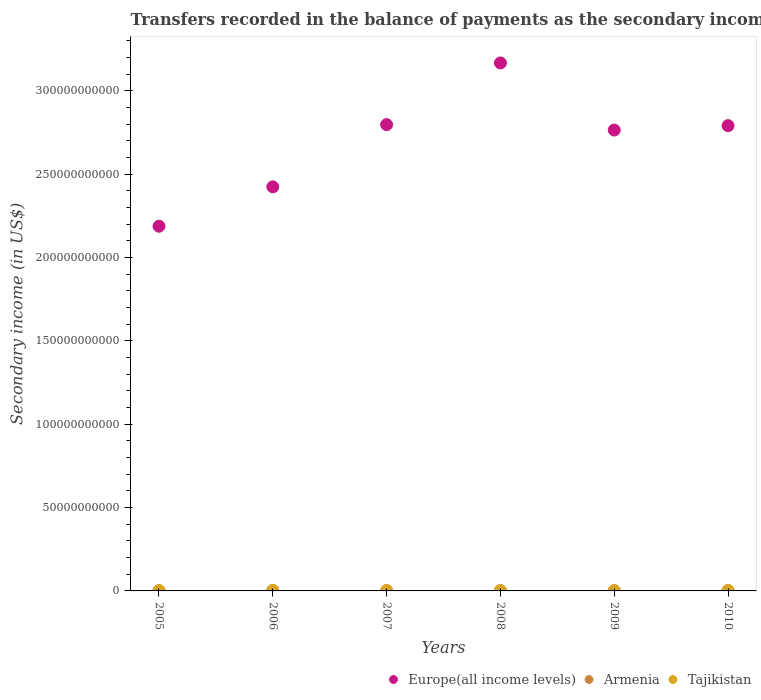Is the number of dotlines equal to the number of legend labels?
Your answer should be very brief. Yes. What is the secondary income of in Europe(all income levels) in 2006?
Offer a terse response. 2.42e+11. Across all years, what is the maximum secondary income of in Armenia?
Give a very brief answer. 2.08e+08. Across all years, what is the minimum secondary income of in Tajikistan?
Keep it short and to the point. 1.27e+08. In which year was the secondary income of in Armenia maximum?
Offer a very short reply. 2008. What is the total secondary income of in Tajikistan in the graph?
Provide a short and direct response. 1.35e+09. What is the difference between the secondary income of in Europe(all income levels) in 2006 and that in 2008?
Your answer should be compact. -7.43e+1. What is the difference between the secondary income of in Europe(all income levels) in 2010 and the secondary income of in Armenia in 2009?
Your answer should be compact. 2.79e+11. What is the average secondary income of in Tajikistan per year?
Provide a succinct answer. 2.25e+08. In the year 2009, what is the difference between the secondary income of in Armenia and secondary income of in Tajikistan?
Provide a short and direct response. 3.81e+07. What is the ratio of the secondary income of in Europe(all income levels) in 2007 to that in 2008?
Provide a short and direct response. 0.88. What is the difference between the highest and the second highest secondary income of in Europe(all income levels)?
Offer a very short reply. 3.70e+1. What is the difference between the highest and the lowest secondary income of in Armenia?
Ensure brevity in your answer.  5.76e+07. Is the sum of the secondary income of in Europe(all income levels) in 2005 and 2009 greater than the maximum secondary income of in Tajikistan across all years?
Keep it short and to the point. Yes. Is it the case that in every year, the sum of the secondary income of in Europe(all income levels) and secondary income of in Armenia  is greater than the secondary income of in Tajikistan?
Your answer should be very brief. Yes. Does the secondary income of in Armenia monotonically increase over the years?
Offer a terse response. No. What is the difference between two consecutive major ticks on the Y-axis?
Ensure brevity in your answer.  5.00e+1. Are the values on the major ticks of Y-axis written in scientific E-notation?
Make the answer very short. No. Does the graph contain any zero values?
Ensure brevity in your answer.  No. Where does the legend appear in the graph?
Make the answer very short. Bottom right. What is the title of the graph?
Ensure brevity in your answer.  Transfers recorded in the balance of payments as the secondary income of a country. What is the label or title of the Y-axis?
Give a very brief answer. Secondary income (in US$). What is the Secondary income (in US$) of Europe(all income levels) in 2005?
Offer a very short reply. 2.19e+11. What is the Secondary income (in US$) in Armenia in 2005?
Keep it short and to the point. 1.53e+08. What is the Secondary income (in US$) in Tajikistan in 2005?
Give a very brief answer. 1.50e+08. What is the Secondary income (in US$) in Europe(all income levels) in 2006?
Give a very brief answer. 2.42e+11. What is the Secondary income (in US$) in Armenia in 2006?
Offer a very short reply. 1.51e+08. What is the Secondary income (in US$) of Tajikistan in 2006?
Offer a terse response. 4.00e+08. What is the Secondary income (in US$) in Europe(all income levels) in 2007?
Give a very brief answer. 2.80e+11. What is the Secondary income (in US$) in Armenia in 2007?
Your answer should be very brief. 2.04e+08. What is the Secondary income (in US$) of Tajikistan in 2007?
Your response must be concise. 2.37e+08. What is the Secondary income (in US$) in Europe(all income levels) in 2008?
Give a very brief answer. 3.17e+11. What is the Secondary income (in US$) in Armenia in 2008?
Ensure brevity in your answer.  2.08e+08. What is the Secondary income (in US$) of Tajikistan in 2008?
Your response must be concise. 2.07e+08. What is the Secondary income (in US$) in Europe(all income levels) in 2009?
Offer a very short reply. 2.76e+11. What is the Secondary income (in US$) of Armenia in 2009?
Keep it short and to the point. 1.65e+08. What is the Secondary income (in US$) of Tajikistan in 2009?
Your answer should be very brief. 1.27e+08. What is the Secondary income (in US$) of Europe(all income levels) in 2010?
Ensure brevity in your answer.  2.79e+11. What is the Secondary income (in US$) in Armenia in 2010?
Offer a terse response. 2.03e+08. What is the Secondary income (in US$) in Tajikistan in 2010?
Offer a very short reply. 2.27e+08. Across all years, what is the maximum Secondary income (in US$) in Europe(all income levels)?
Your answer should be compact. 3.17e+11. Across all years, what is the maximum Secondary income (in US$) of Armenia?
Your answer should be compact. 2.08e+08. Across all years, what is the maximum Secondary income (in US$) of Tajikistan?
Provide a succinct answer. 4.00e+08. Across all years, what is the minimum Secondary income (in US$) of Europe(all income levels)?
Your answer should be very brief. 2.19e+11. Across all years, what is the minimum Secondary income (in US$) in Armenia?
Provide a short and direct response. 1.51e+08. Across all years, what is the minimum Secondary income (in US$) of Tajikistan?
Offer a very short reply. 1.27e+08. What is the total Secondary income (in US$) of Europe(all income levels) in the graph?
Ensure brevity in your answer.  1.61e+12. What is the total Secondary income (in US$) of Armenia in the graph?
Make the answer very short. 1.08e+09. What is the total Secondary income (in US$) in Tajikistan in the graph?
Keep it short and to the point. 1.35e+09. What is the difference between the Secondary income (in US$) of Europe(all income levels) in 2005 and that in 2006?
Offer a very short reply. -2.36e+1. What is the difference between the Secondary income (in US$) of Armenia in 2005 and that in 2006?
Your response must be concise. 2.45e+06. What is the difference between the Secondary income (in US$) of Tajikistan in 2005 and that in 2006?
Give a very brief answer. -2.50e+08. What is the difference between the Secondary income (in US$) of Europe(all income levels) in 2005 and that in 2007?
Your answer should be compact. -6.10e+1. What is the difference between the Secondary income (in US$) of Armenia in 2005 and that in 2007?
Your response must be concise. -5.10e+07. What is the difference between the Secondary income (in US$) in Tajikistan in 2005 and that in 2007?
Your response must be concise. -8.72e+07. What is the difference between the Secondary income (in US$) of Europe(all income levels) in 2005 and that in 2008?
Provide a short and direct response. -9.80e+1. What is the difference between the Secondary income (in US$) of Armenia in 2005 and that in 2008?
Your response must be concise. -5.51e+07. What is the difference between the Secondary income (in US$) of Tajikistan in 2005 and that in 2008?
Provide a short and direct response. -5.68e+07. What is the difference between the Secondary income (in US$) in Europe(all income levels) in 2005 and that in 2009?
Make the answer very short. -5.77e+1. What is the difference between the Secondary income (in US$) of Armenia in 2005 and that in 2009?
Your answer should be very brief. -1.18e+07. What is the difference between the Secondary income (in US$) of Tajikistan in 2005 and that in 2009?
Make the answer very short. 2.31e+07. What is the difference between the Secondary income (in US$) of Europe(all income levels) in 2005 and that in 2010?
Your response must be concise. -6.03e+1. What is the difference between the Secondary income (in US$) in Armenia in 2005 and that in 2010?
Make the answer very short. -4.98e+07. What is the difference between the Secondary income (in US$) of Tajikistan in 2005 and that in 2010?
Provide a short and direct response. -7.67e+07. What is the difference between the Secondary income (in US$) of Europe(all income levels) in 2006 and that in 2007?
Offer a terse response. -3.73e+1. What is the difference between the Secondary income (in US$) in Armenia in 2006 and that in 2007?
Give a very brief answer. -5.34e+07. What is the difference between the Secondary income (in US$) in Tajikistan in 2006 and that in 2007?
Your answer should be compact. 1.63e+08. What is the difference between the Secondary income (in US$) of Europe(all income levels) in 2006 and that in 2008?
Offer a very short reply. -7.43e+1. What is the difference between the Secondary income (in US$) of Armenia in 2006 and that in 2008?
Ensure brevity in your answer.  -5.76e+07. What is the difference between the Secondary income (in US$) in Tajikistan in 2006 and that in 2008?
Your response must be concise. 1.94e+08. What is the difference between the Secondary income (in US$) in Europe(all income levels) in 2006 and that in 2009?
Provide a succinct answer. -3.41e+1. What is the difference between the Secondary income (in US$) in Armenia in 2006 and that in 2009?
Offer a terse response. -1.43e+07. What is the difference between the Secondary income (in US$) of Tajikistan in 2006 and that in 2009?
Offer a terse response. 2.73e+08. What is the difference between the Secondary income (in US$) of Europe(all income levels) in 2006 and that in 2010?
Ensure brevity in your answer.  -3.67e+1. What is the difference between the Secondary income (in US$) of Armenia in 2006 and that in 2010?
Offer a terse response. -5.23e+07. What is the difference between the Secondary income (in US$) in Tajikistan in 2006 and that in 2010?
Provide a succinct answer. 1.74e+08. What is the difference between the Secondary income (in US$) in Europe(all income levels) in 2007 and that in 2008?
Provide a succinct answer. -3.70e+1. What is the difference between the Secondary income (in US$) in Armenia in 2007 and that in 2008?
Provide a short and direct response. -4.16e+06. What is the difference between the Secondary income (in US$) in Tajikistan in 2007 and that in 2008?
Give a very brief answer. 3.03e+07. What is the difference between the Secondary income (in US$) of Europe(all income levels) in 2007 and that in 2009?
Keep it short and to the point. 3.27e+09. What is the difference between the Secondary income (in US$) of Armenia in 2007 and that in 2009?
Keep it short and to the point. 3.92e+07. What is the difference between the Secondary income (in US$) in Tajikistan in 2007 and that in 2009?
Your response must be concise. 1.10e+08. What is the difference between the Secondary income (in US$) of Europe(all income levels) in 2007 and that in 2010?
Your answer should be very brief. 6.19e+08. What is the difference between the Secondary income (in US$) of Armenia in 2007 and that in 2010?
Offer a very short reply. 1.17e+06. What is the difference between the Secondary income (in US$) in Tajikistan in 2007 and that in 2010?
Your answer should be compact. 1.05e+07. What is the difference between the Secondary income (in US$) of Europe(all income levels) in 2008 and that in 2009?
Give a very brief answer. 4.03e+1. What is the difference between the Secondary income (in US$) in Armenia in 2008 and that in 2009?
Your answer should be very brief. 4.33e+07. What is the difference between the Secondary income (in US$) in Tajikistan in 2008 and that in 2009?
Offer a terse response. 7.99e+07. What is the difference between the Secondary income (in US$) of Europe(all income levels) in 2008 and that in 2010?
Offer a terse response. 3.76e+1. What is the difference between the Secondary income (in US$) in Armenia in 2008 and that in 2010?
Your answer should be very brief. 5.33e+06. What is the difference between the Secondary income (in US$) of Tajikistan in 2008 and that in 2010?
Your answer should be very brief. -1.98e+07. What is the difference between the Secondary income (in US$) in Europe(all income levels) in 2009 and that in 2010?
Give a very brief answer. -2.65e+09. What is the difference between the Secondary income (in US$) in Armenia in 2009 and that in 2010?
Offer a terse response. -3.80e+07. What is the difference between the Secondary income (in US$) in Tajikistan in 2009 and that in 2010?
Provide a succinct answer. -9.97e+07. What is the difference between the Secondary income (in US$) of Europe(all income levels) in 2005 and the Secondary income (in US$) of Armenia in 2006?
Your answer should be compact. 2.19e+11. What is the difference between the Secondary income (in US$) of Europe(all income levels) in 2005 and the Secondary income (in US$) of Tajikistan in 2006?
Offer a terse response. 2.18e+11. What is the difference between the Secondary income (in US$) of Armenia in 2005 and the Secondary income (in US$) of Tajikistan in 2006?
Provide a succinct answer. -2.47e+08. What is the difference between the Secondary income (in US$) of Europe(all income levels) in 2005 and the Secondary income (in US$) of Armenia in 2007?
Provide a short and direct response. 2.19e+11. What is the difference between the Secondary income (in US$) of Europe(all income levels) in 2005 and the Secondary income (in US$) of Tajikistan in 2007?
Ensure brevity in your answer.  2.19e+11. What is the difference between the Secondary income (in US$) in Armenia in 2005 and the Secondary income (in US$) in Tajikistan in 2007?
Give a very brief answer. -8.39e+07. What is the difference between the Secondary income (in US$) in Europe(all income levels) in 2005 and the Secondary income (in US$) in Armenia in 2008?
Give a very brief answer. 2.19e+11. What is the difference between the Secondary income (in US$) of Europe(all income levels) in 2005 and the Secondary income (in US$) of Tajikistan in 2008?
Keep it short and to the point. 2.19e+11. What is the difference between the Secondary income (in US$) of Armenia in 2005 and the Secondary income (in US$) of Tajikistan in 2008?
Keep it short and to the point. -5.36e+07. What is the difference between the Secondary income (in US$) in Europe(all income levels) in 2005 and the Secondary income (in US$) in Armenia in 2009?
Your answer should be compact. 2.19e+11. What is the difference between the Secondary income (in US$) in Europe(all income levels) in 2005 and the Secondary income (in US$) in Tajikistan in 2009?
Offer a very short reply. 2.19e+11. What is the difference between the Secondary income (in US$) of Armenia in 2005 and the Secondary income (in US$) of Tajikistan in 2009?
Ensure brevity in your answer.  2.63e+07. What is the difference between the Secondary income (in US$) in Europe(all income levels) in 2005 and the Secondary income (in US$) in Armenia in 2010?
Make the answer very short. 2.19e+11. What is the difference between the Secondary income (in US$) of Europe(all income levels) in 2005 and the Secondary income (in US$) of Tajikistan in 2010?
Provide a succinct answer. 2.19e+11. What is the difference between the Secondary income (in US$) of Armenia in 2005 and the Secondary income (in US$) of Tajikistan in 2010?
Provide a short and direct response. -7.34e+07. What is the difference between the Secondary income (in US$) in Europe(all income levels) in 2006 and the Secondary income (in US$) in Armenia in 2007?
Your answer should be compact. 2.42e+11. What is the difference between the Secondary income (in US$) in Europe(all income levels) in 2006 and the Secondary income (in US$) in Tajikistan in 2007?
Make the answer very short. 2.42e+11. What is the difference between the Secondary income (in US$) of Armenia in 2006 and the Secondary income (in US$) of Tajikistan in 2007?
Ensure brevity in your answer.  -8.64e+07. What is the difference between the Secondary income (in US$) of Europe(all income levels) in 2006 and the Secondary income (in US$) of Armenia in 2008?
Provide a succinct answer. 2.42e+11. What is the difference between the Secondary income (in US$) of Europe(all income levels) in 2006 and the Secondary income (in US$) of Tajikistan in 2008?
Give a very brief answer. 2.42e+11. What is the difference between the Secondary income (in US$) in Armenia in 2006 and the Secondary income (in US$) in Tajikistan in 2008?
Make the answer very short. -5.61e+07. What is the difference between the Secondary income (in US$) in Europe(all income levels) in 2006 and the Secondary income (in US$) in Armenia in 2009?
Offer a very short reply. 2.42e+11. What is the difference between the Secondary income (in US$) of Europe(all income levels) in 2006 and the Secondary income (in US$) of Tajikistan in 2009?
Your answer should be very brief. 2.42e+11. What is the difference between the Secondary income (in US$) in Armenia in 2006 and the Secondary income (in US$) in Tajikistan in 2009?
Keep it short and to the point. 2.38e+07. What is the difference between the Secondary income (in US$) in Europe(all income levels) in 2006 and the Secondary income (in US$) in Armenia in 2010?
Provide a succinct answer. 2.42e+11. What is the difference between the Secondary income (in US$) of Europe(all income levels) in 2006 and the Secondary income (in US$) of Tajikistan in 2010?
Your response must be concise. 2.42e+11. What is the difference between the Secondary income (in US$) in Armenia in 2006 and the Secondary income (in US$) in Tajikistan in 2010?
Give a very brief answer. -7.59e+07. What is the difference between the Secondary income (in US$) in Europe(all income levels) in 2007 and the Secondary income (in US$) in Armenia in 2008?
Your response must be concise. 2.80e+11. What is the difference between the Secondary income (in US$) in Europe(all income levels) in 2007 and the Secondary income (in US$) in Tajikistan in 2008?
Provide a succinct answer. 2.80e+11. What is the difference between the Secondary income (in US$) in Armenia in 2007 and the Secondary income (in US$) in Tajikistan in 2008?
Provide a short and direct response. -2.63e+06. What is the difference between the Secondary income (in US$) of Europe(all income levels) in 2007 and the Secondary income (in US$) of Armenia in 2009?
Your answer should be very brief. 2.80e+11. What is the difference between the Secondary income (in US$) in Europe(all income levels) in 2007 and the Secondary income (in US$) in Tajikistan in 2009?
Your answer should be compact. 2.80e+11. What is the difference between the Secondary income (in US$) of Armenia in 2007 and the Secondary income (in US$) of Tajikistan in 2009?
Keep it short and to the point. 7.73e+07. What is the difference between the Secondary income (in US$) of Europe(all income levels) in 2007 and the Secondary income (in US$) of Armenia in 2010?
Provide a succinct answer. 2.80e+11. What is the difference between the Secondary income (in US$) of Europe(all income levels) in 2007 and the Secondary income (in US$) of Tajikistan in 2010?
Your answer should be very brief. 2.80e+11. What is the difference between the Secondary income (in US$) of Armenia in 2007 and the Secondary income (in US$) of Tajikistan in 2010?
Offer a terse response. -2.25e+07. What is the difference between the Secondary income (in US$) of Europe(all income levels) in 2008 and the Secondary income (in US$) of Armenia in 2009?
Give a very brief answer. 3.17e+11. What is the difference between the Secondary income (in US$) of Europe(all income levels) in 2008 and the Secondary income (in US$) of Tajikistan in 2009?
Make the answer very short. 3.17e+11. What is the difference between the Secondary income (in US$) of Armenia in 2008 and the Secondary income (in US$) of Tajikistan in 2009?
Provide a short and direct response. 8.14e+07. What is the difference between the Secondary income (in US$) in Europe(all income levels) in 2008 and the Secondary income (in US$) in Armenia in 2010?
Offer a very short reply. 3.17e+11. What is the difference between the Secondary income (in US$) in Europe(all income levels) in 2008 and the Secondary income (in US$) in Tajikistan in 2010?
Provide a short and direct response. 3.17e+11. What is the difference between the Secondary income (in US$) of Armenia in 2008 and the Secondary income (in US$) of Tajikistan in 2010?
Offer a terse response. -1.83e+07. What is the difference between the Secondary income (in US$) in Europe(all income levels) in 2009 and the Secondary income (in US$) in Armenia in 2010?
Your response must be concise. 2.76e+11. What is the difference between the Secondary income (in US$) of Europe(all income levels) in 2009 and the Secondary income (in US$) of Tajikistan in 2010?
Ensure brevity in your answer.  2.76e+11. What is the difference between the Secondary income (in US$) in Armenia in 2009 and the Secondary income (in US$) in Tajikistan in 2010?
Offer a terse response. -6.16e+07. What is the average Secondary income (in US$) of Europe(all income levels) per year?
Give a very brief answer. 2.69e+11. What is the average Secondary income (in US$) in Armenia per year?
Provide a short and direct response. 1.81e+08. What is the average Secondary income (in US$) in Tajikistan per year?
Make the answer very short. 2.25e+08. In the year 2005, what is the difference between the Secondary income (in US$) of Europe(all income levels) and Secondary income (in US$) of Armenia?
Ensure brevity in your answer.  2.19e+11. In the year 2005, what is the difference between the Secondary income (in US$) in Europe(all income levels) and Secondary income (in US$) in Tajikistan?
Your answer should be compact. 2.19e+11. In the year 2005, what is the difference between the Secondary income (in US$) of Armenia and Secondary income (in US$) of Tajikistan?
Give a very brief answer. 3.24e+06. In the year 2006, what is the difference between the Secondary income (in US$) of Europe(all income levels) and Secondary income (in US$) of Armenia?
Your answer should be compact. 2.42e+11. In the year 2006, what is the difference between the Secondary income (in US$) of Europe(all income levels) and Secondary income (in US$) of Tajikistan?
Offer a very short reply. 2.42e+11. In the year 2006, what is the difference between the Secondary income (in US$) in Armenia and Secondary income (in US$) in Tajikistan?
Ensure brevity in your answer.  -2.50e+08. In the year 2007, what is the difference between the Secondary income (in US$) in Europe(all income levels) and Secondary income (in US$) in Armenia?
Offer a very short reply. 2.80e+11. In the year 2007, what is the difference between the Secondary income (in US$) of Europe(all income levels) and Secondary income (in US$) of Tajikistan?
Your answer should be compact. 2.80e+11. In the year 2007, what is the difference between the Secondary income (in US$) in Armenia and Secondary income (in US$) in Tajikistan?
Give a very brief answer. -3.29e+07. In the year 2008, what is the difference between the Secondary income (in US$) of Europe(all income levels) and Secondary income (in US$) of Armenia?
Your answer should be very brief. 3.17e+11. In the year 2008, what is the difference between the Secondary income (in US$) of Europe(all income levels) and Secondary income (in US$) of Tajikistan?
Provide a short and direct response. 3.17e+11. In the year 2008, what is the difference between the Secondary income (in US$) in Armenia and Secondary income (in US$) in Tajikistan?
Your answer should be very brief. 1.53e+06. In the year 2009, what is the difference between the Secondary income (in US$) of Europe(all income levels) and Secondary income (in US$) of Armenia?
Offer a terse response. 2.76e+11. In the year 2009, what is the difference between the Secondary income (in US$) in Europe(all income levels) and Secondary income (in US$) in Tajikistan?
Ensure brevity in your answer.  2.76e+11. In the year 2009, what is the difference between the Secondary income (in US$) of Armenia and Secondary income (in US$) of Tajikistan?
Your answer should be very brief. 3.81e+07. In the year 2010, what is the difference between the Secondary income (in US$) in Europe(all income levels) and Secondary income (in US$) in Armenia?
Offer a terse response. 2.79e+11. In the year 2010, what is the difference between the Secondary income (in US$) in Europe(all income levels) and Secondary income (in US$) in Tajikistan?
Keep it short and to the point. 2.79e+11. In the year 2010, what is the difference between the Secondary income (in US$) in Armenia and Secondary income (in US$) in Tajikistan?
Give a very brief answer. -2.36e+07. What is the ratio of the Secondary income (in US$) of Europe(all income levels) in 2005 to that in 2006?
Provide a succinct answer. 0.9. What is the ratio of the Secondary income (in US$) in Armenia in 2005 to that in 2006?
Your answer should be compact. 1.02. What is the ratio of the Secondary income (in US$) of Tajikistan in 2005 to that in 2006?
Your answer should be very brief. 0.37. What is the ratio of the Secondary income (in US$) in Europe(all income levels) in 2005 to that in 2007?
Provide a short and direct response. 0.78. What is the ratio of the Secondary income (in US$) in Armenia in 2005 to that in 2007?
Your answer should be compact. 0.75. What is the ratio of the Secondary income (in US$) of Tajikistan in 2005 to that in 2007?
Make the answer very short. 0.63. What is the ratio of the Secondary income (in US$) of Europe(all income levels) in 2005 to that in 2008?
Offer a terse response. 0.69. What is the ratio of the Secondary income (in US$) in Armenia in 2005 to that in 2008?
Make the answer very short. 0.74. What is the ratio of the Secondary income (in US$) in Tajikistan in 2005 to that in 2008?
Give a very brief answer. 0.73. What is the ratio of the Secondary income (in US$) in Europe(all income levels) in 2005 to that in 2009?
Your answer should be compact. 0.79. What is the ratio of the Secondary income (in US$) in Armenia in 2005 to that in 2009?
Your response must be concise. 0.93. What is the ratio of the Secondary income (in US$) in Tajikistan in 2005 to that in 2009?
Your answer should be very brief. 1.18. What is the ratio of the Secondary income (in US$) of Europe(all income levels) in 2005 to that in 2010?
Make the answer very short. 0.78. What is the ratio of the Secondary income (in US$) in Armenia in 2005 to that in 2010?
Offer a very short reply. 0.75. What is the ratio of the Secondary income (in US$) of Tajikistan in 2005 to that in 2010?
Ensure brevity in your answer.  0.66. What is the ratio of the Secondary income (in US$) in Europe(all income levels) in 2006 to that in 2007?
Make the answer very short. 0.87. What is the ratio of the Secondary income (in US$) in Armenia in 2006 to that in 2007?
Offer a terse response. 0.74. What is the ratio of the Secondary income (in US$) of Tajikistan in 2006 to that in 2007?
Ensure brevity in your answer.  1.69. What is the ratio of the Secondary income (in US$) of Europe(all income levels) in 2006 to that in 2008?
Give a very brief answer. 0.77. What is the ratio of the Secondary income (in US$) of Armenia in 2006 to that in 2008?
Offer a terse response. 0.72. What is the ratio of the Secondary income (in US$) in Tajikistan in 2006 to that in 2008?
Provide a short and direct response. 1.94. What is the ratio of the Secondary income (in US$) in Europe(all income levels) in 2006 to that in 2009?
Give a very brief answer. 0.88. What is the ratio of the Secondary income (in US$) in Armenia in 2006 to that in 2009?
Keep it short and to the point. 0.91. What is the ratio of the Secondary income (in US$) in Tajikistan in 2006 to that in 2009?
Keep it short and to the point. 3.15. What is the ratio of the Secondary income (in US$) in Europe(all income levels) in 2006 to that in 2010?
Provide a short and direct response. 0.87. What is the ratio of the Secondary income (in US$) in Armenia in 2006 to that in 2010?
Your answer should be compact. 0.74. What is the ratio of the Secondary income (in US$) of Tajikistan in 2006 to that in 2010?
Ensure brevity in your answer.  1.77. What is the ratio of the Secondary income (in US$) in Europe(all income levels) in 2007 to that in 2008?
Your answer should be very brief. 0.88. What is the ratio of the Secondary income (in US$) of Armenia in 2007 to that in 2008?
Provide a succinct answer. 0.98. What is the ratio of the Secondary income (in US$) of Tajikistan in 2007 to that in 2008?
Keep it short and to the point. 1.15. What is the ratio of the Secondary income (in US$) of Europe(all income levels) in 2007 to that in 2009?
Offer a very short reply. 1.01. What is the ratio of the Secondary income (in US$) of Armenia in 2007 to that in 2009?
Offer a very short reply. 1.24. What is the ratio of the Secondary income (in US$) in Tajikistan in 2007 to that in 2009?
Your answer should be very brief. 1.87. What is the ratio of the Secondary income (in US$) of Europe(all income levels) in 2007 to that in 2010?
Your response must be concise. 1. What is the ratio of the Secondary income (in US$) of Tajikistan in 2007 to that in 2010?
Your answer should be very brief. 1.05. What is the ratio of the Secondary income (in US$) in Europe(all income levels) in 2008 to that in 2009?
Provide a succinct answer. 1.15. What is the ratio of the Secondary income (in US$) in Armenia in 2008 to that in 2009?
Make the answer very short. 1.26. What is the ratio of the Secondary income (in US$) of Tajikistan in 2008 to that in 2009?
Make the answer very short. 1.63. What is the ratio of the Secondary income (in US$) of Europe(all income levels) in 2008 to that in 2010?
Ensure brevity in your answer.  1.13. What is the ratio of the Secondary income (in US$) of Armenia in 2008 to that in 2010?
Provide a short and direct response. 1.03. What is the ratio of the Secondary income (in US$) of Tajikistan in 2008 to that in 2010?
Make the answer very short. 0.91. What is the ratio of the Secondary income (in US$) in Europe(all income levels) in 2009 to that in 2010?
Your answer should be compact. 0.99. What is the ratio of the Secondary income (in US$) of Armenia in 2009 to that in 2010?
Keep it short and to the point. 0.81. What is the ratio of the Secondary income (in US$) in Tajikistan in 2009 to that in 2010?
Keep it short and to the point. 0.56. What is the difference between the highest and the second highest Secondary income (in US$) in Europe(all income levels)?
Your answer should be compact. 3.70e+1. What is the difference between the highest and the second highest Secondary income (in US$) in Armenia?
Offer a very short reply. 4.16e+06. What is the difference between the highest and the second highest Secondary income (in US$) in Tajikistan?
Give a very brief answer. 1.63e+08. What is the difference between the highest and the lowest Secondary income (in US$) of Europe(all income levels)?
Your answer should be compact. 9.80e+1. What is the difference between the highest and the lowest Secondary income (in US$) of Armenia?
Your response must be concise. 5.76e+07. What is the difference between the highest and the lowest Secondary income (in US$) in Tajikistan?
Your answer should be compact. 2.73e+08. 